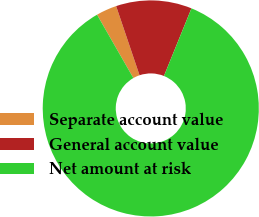Convert chart to OTSL. <chart><loc_0><loc_0><loc_500><loc_500><pie_chart><fcel>Separate account value<fcel>General account value<fcel>Net amount at risk<nl><fcel>3.09%<fcel>11.34%<fcel>85.57%<nl></chart> 